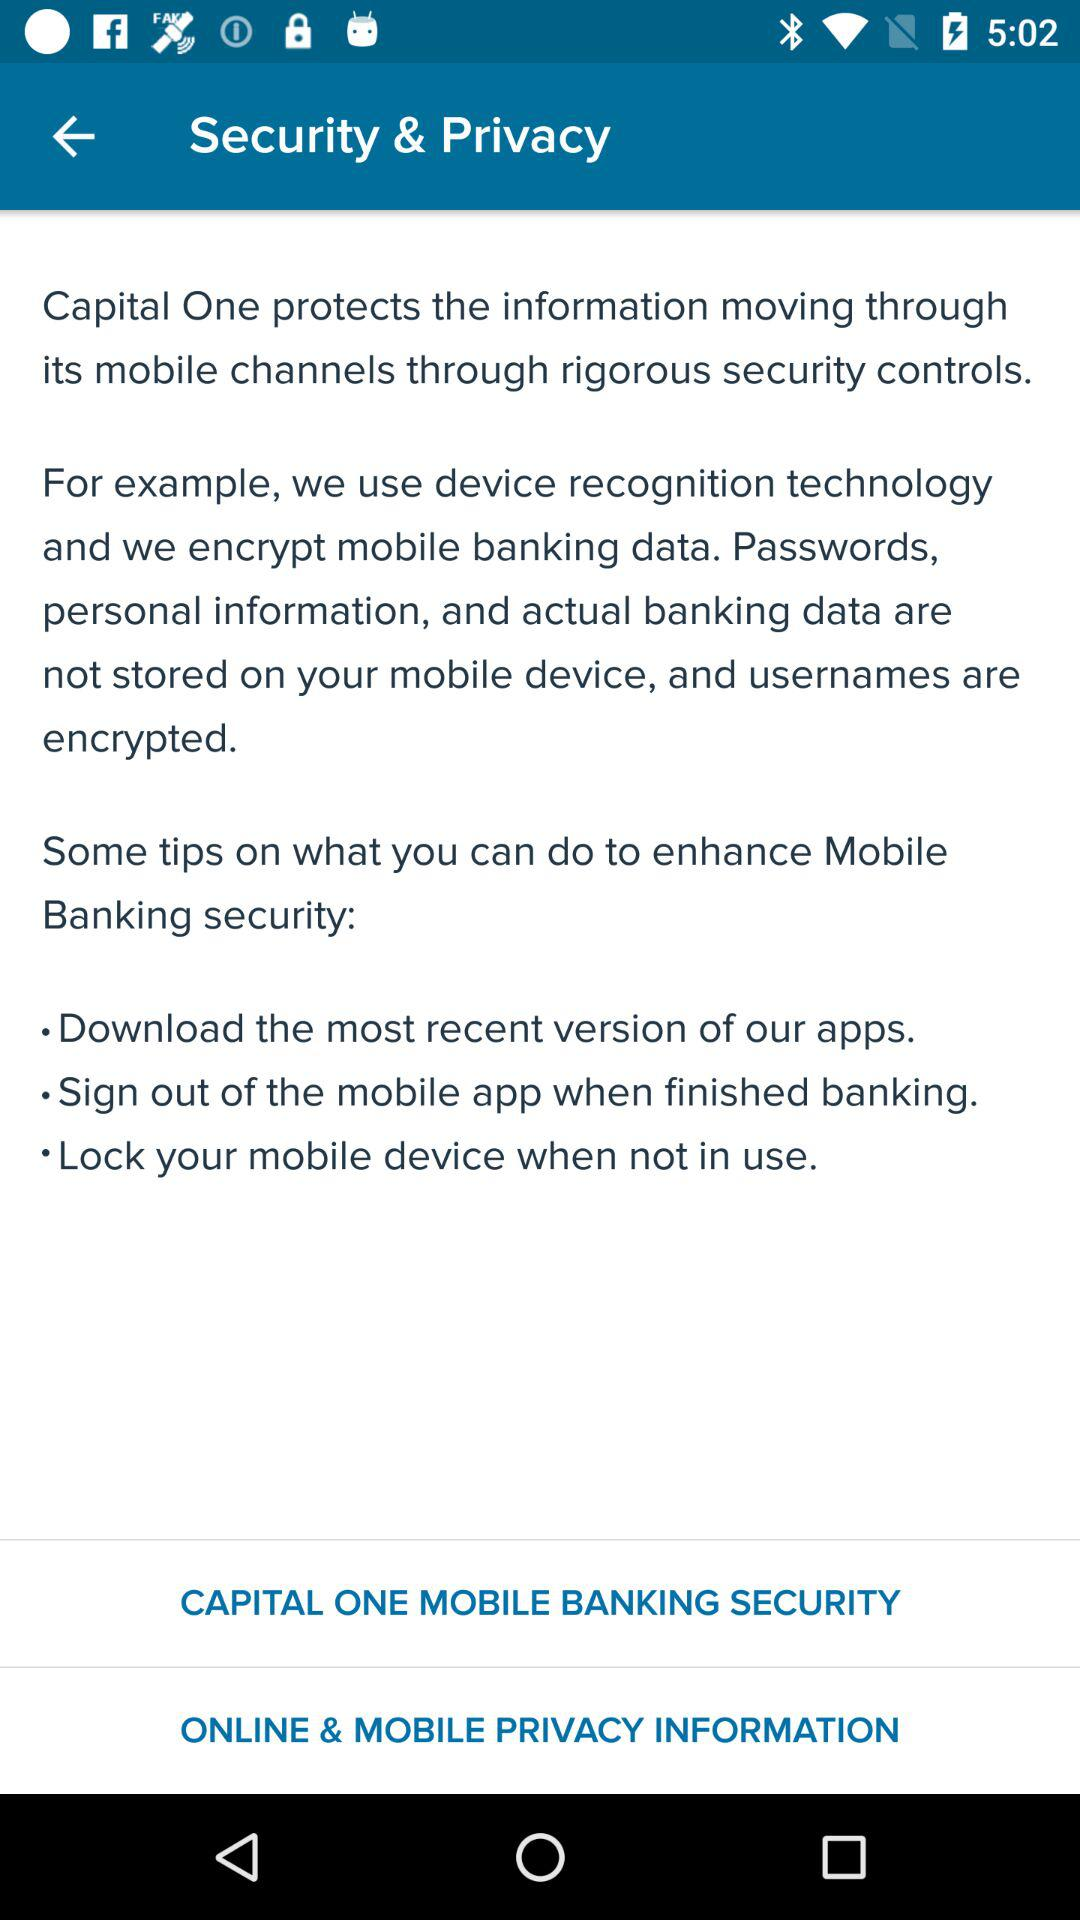How many tips are provided on how to enhance Mobile Banking security?
Answer the question using a single word or phrase. 3 